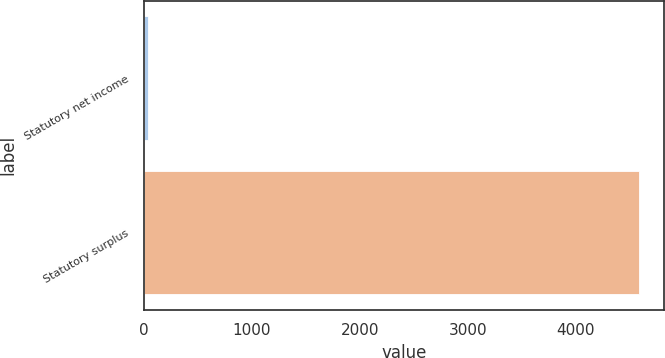<chart> <loc_0><loc_0><loc_500><loc_500><bar_chart><fcel>Statutory net income<fcel>Statutory surplus<nl><fcel>42.1<fcel>4586.2<nl></chart> 